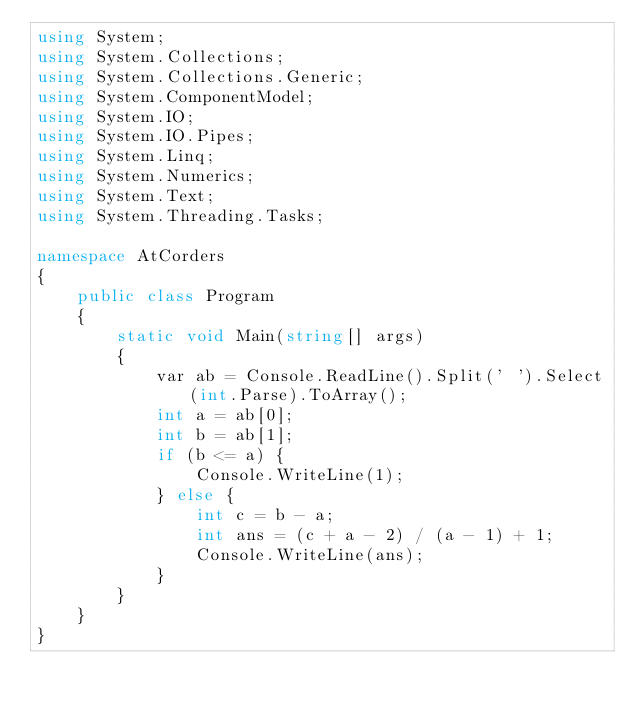<code> <loc_0><loc_0><loc_500><loc_500><_C#_>using System;
using System.Collections;
using System.Collections.Generic;
using System.ComponentModel;
using System.IO;
using System.IO.Pipes;
using System.Linq;
using System.Numerics;
using System.Text;
using System.Threading.Tasks;

namespace AtCorders
{
	public class Program
	{
		static void Main(string[] args)
		{
			var ab = Console.ReadLine().Split(' ').Select(int.Parse).ToArray();
			int a = ab[0];
			int b = ab[1];
			if (b <= a) {
				Console.WriteLine(1);
			} else {
				int c = b - a;
				int ans = (c + a - 2) / (a - 1) + 1;
				Console.WriteLine(ans);
			}
		}
	}
}</code> 